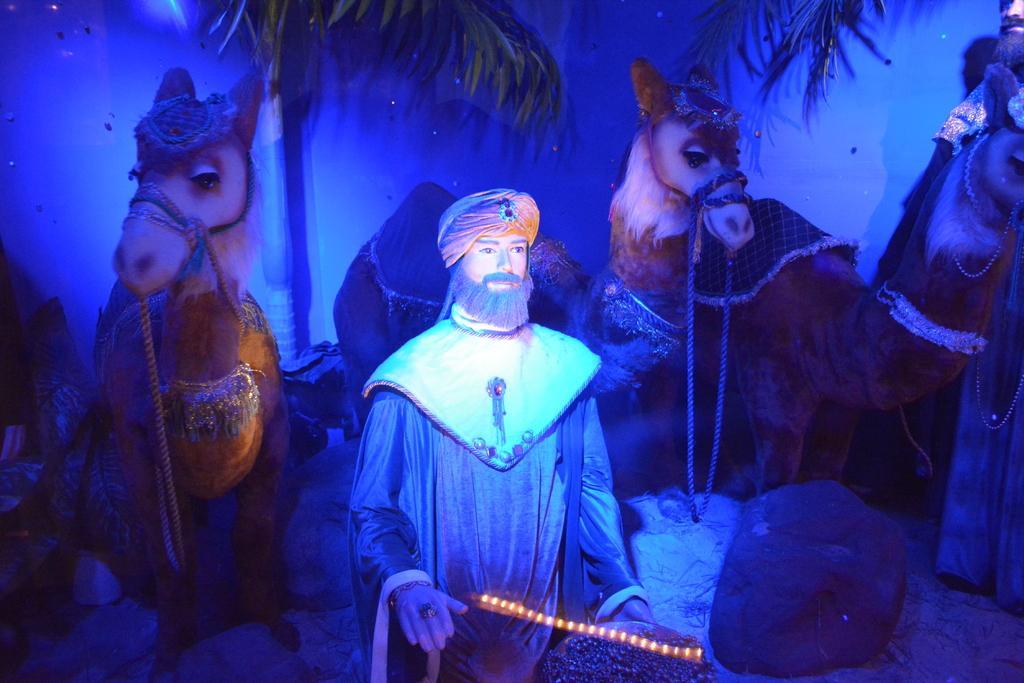Can you describe this image briefly? In this image I can see sculpture of two men and of three camels. I can also see few lights in the front and on the top side of this image I can see leaves. I can also see a stone on the right side of this image. 